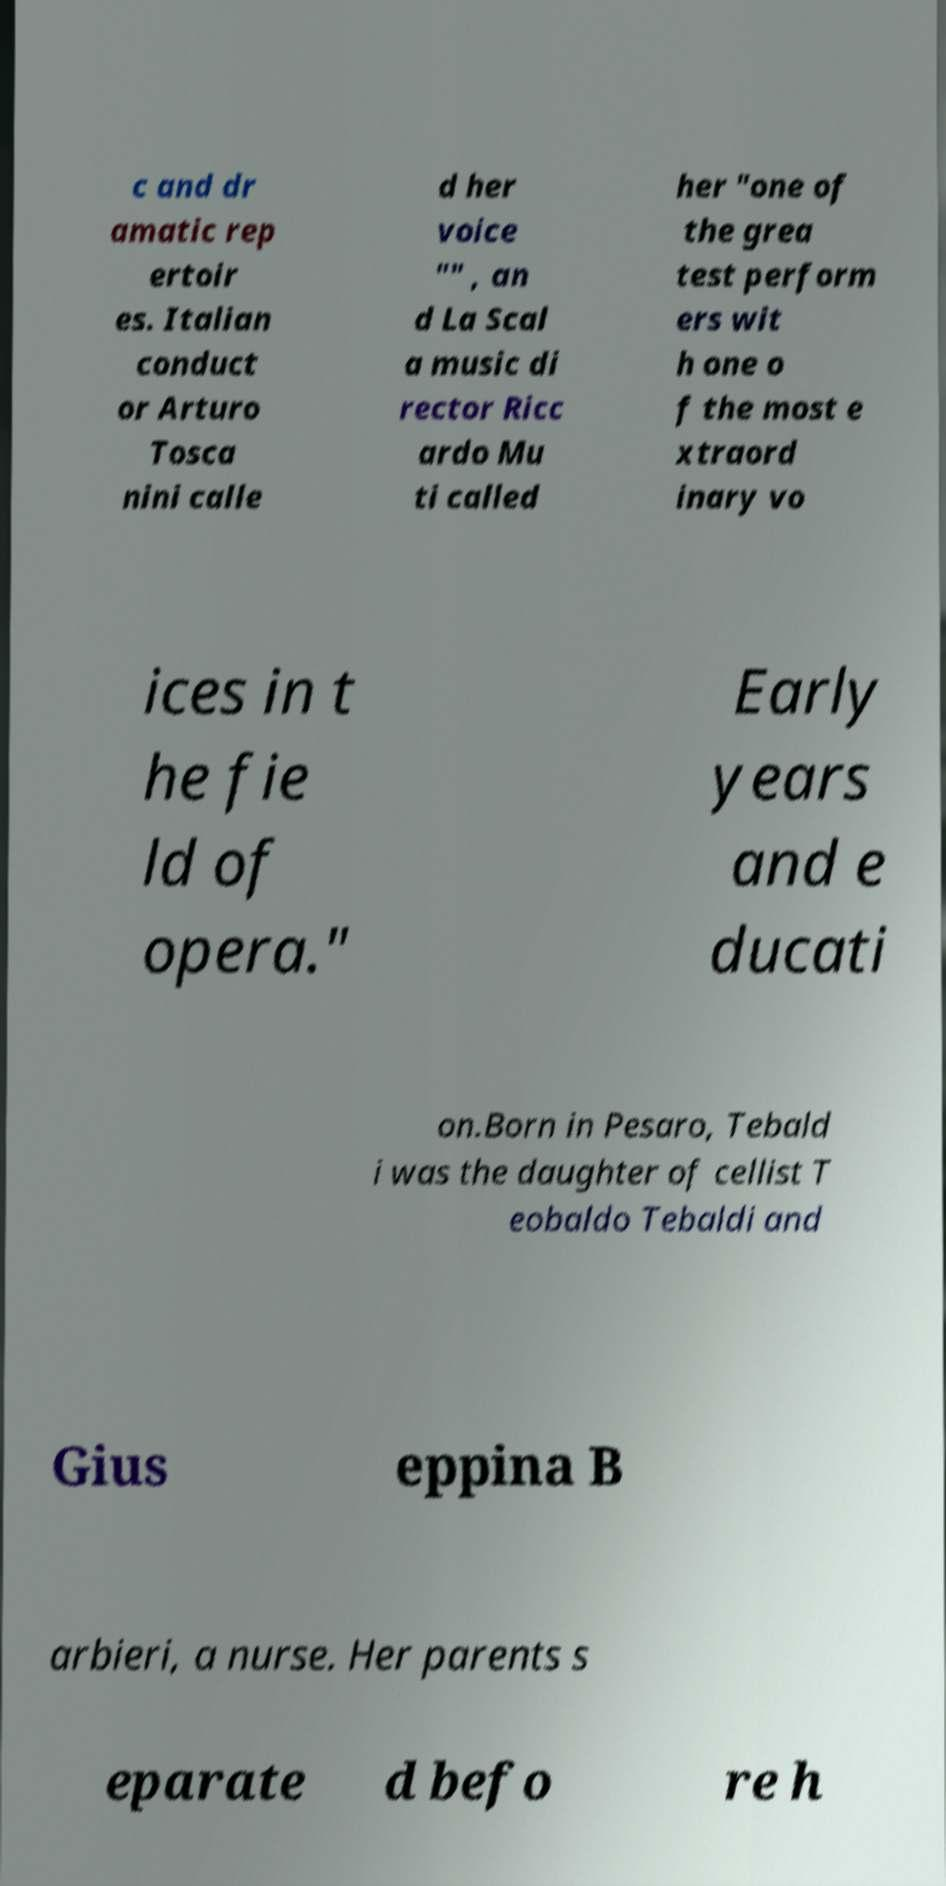For documentation purposes, I need the text within this image transcribed. Could you provide that? c and dr amatic rep ertoir es. Italian conduct or Arturo Tosca nini calle d her voice "" , an d La Scal a music di rector Ricc ardo Mu ti called her "one of the grea test perform ers wit h one o f the most e xtraord inary vo ices in t he fie ld of opera." Early years and e ducati on.Born in Pesaro, Tebald i was the daughter of cellist T eobaldo Tebaldi and Gius eppina B arbieri, a nurse. Her parents s eparate d befo re h 